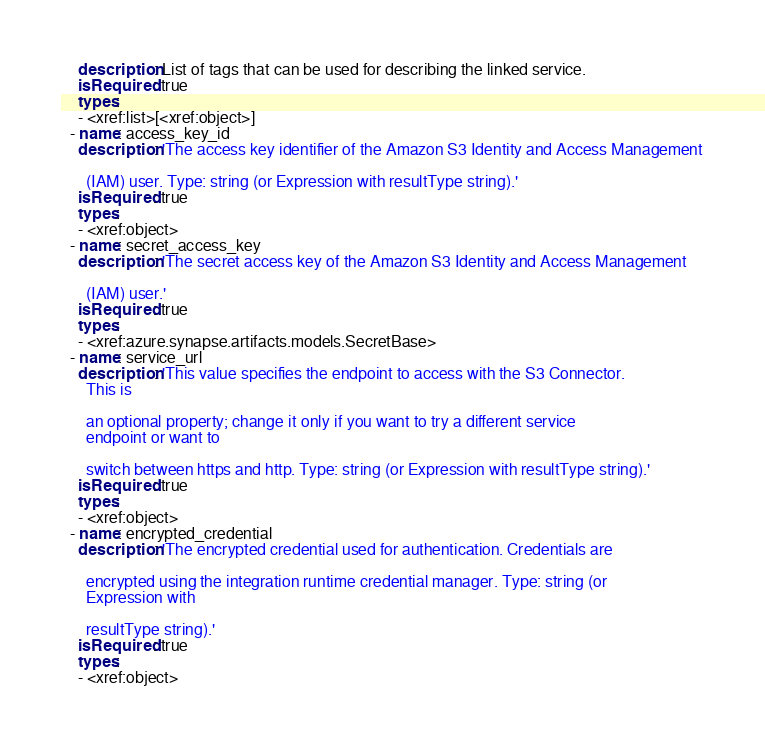<code> <loc_0><loc_0><loc_500><loc_500><_YAML_>    description: List of tags that can be used for describing the linked service.
    isRequired: true
    types:
    - <xref:list>[<xref:object>]
  - name: access_key_id
    description: 'The access key identifier of the Amazon S3 Identity and Access Management

      (IAM) user. Type: string (or Expression with resultType string).'
    isRequired: true
    types:
    - <xref:object>
  - name: secret_access_key
    description: 'The secret access key of the Amazon S3 Identity and Access Management

      (IAM) user.'
    isRequired: true
    types:
    - <xref:azure.synapse.artifacts.models.SecretBase>
  - name: service_url
    description: 'This value specifies the endpoint to access with the S3 Connector.
      This is

      an optional property; change it only if you want to try a different service
      endpoint or want to

      switch between https and http. Type: string (or Expression with resultType string).'
    isRequired: true
    types:
    - <xref:object>
  - name: encrypted_credential
    description: 'The encrypted credential used for authentication. Credentials are

      encrypted using the integration runtime credential manager. Type: string (or
      Expression with

      resultType string).'
    isRequired: true
    types:
    - <xref:object>
</code> 